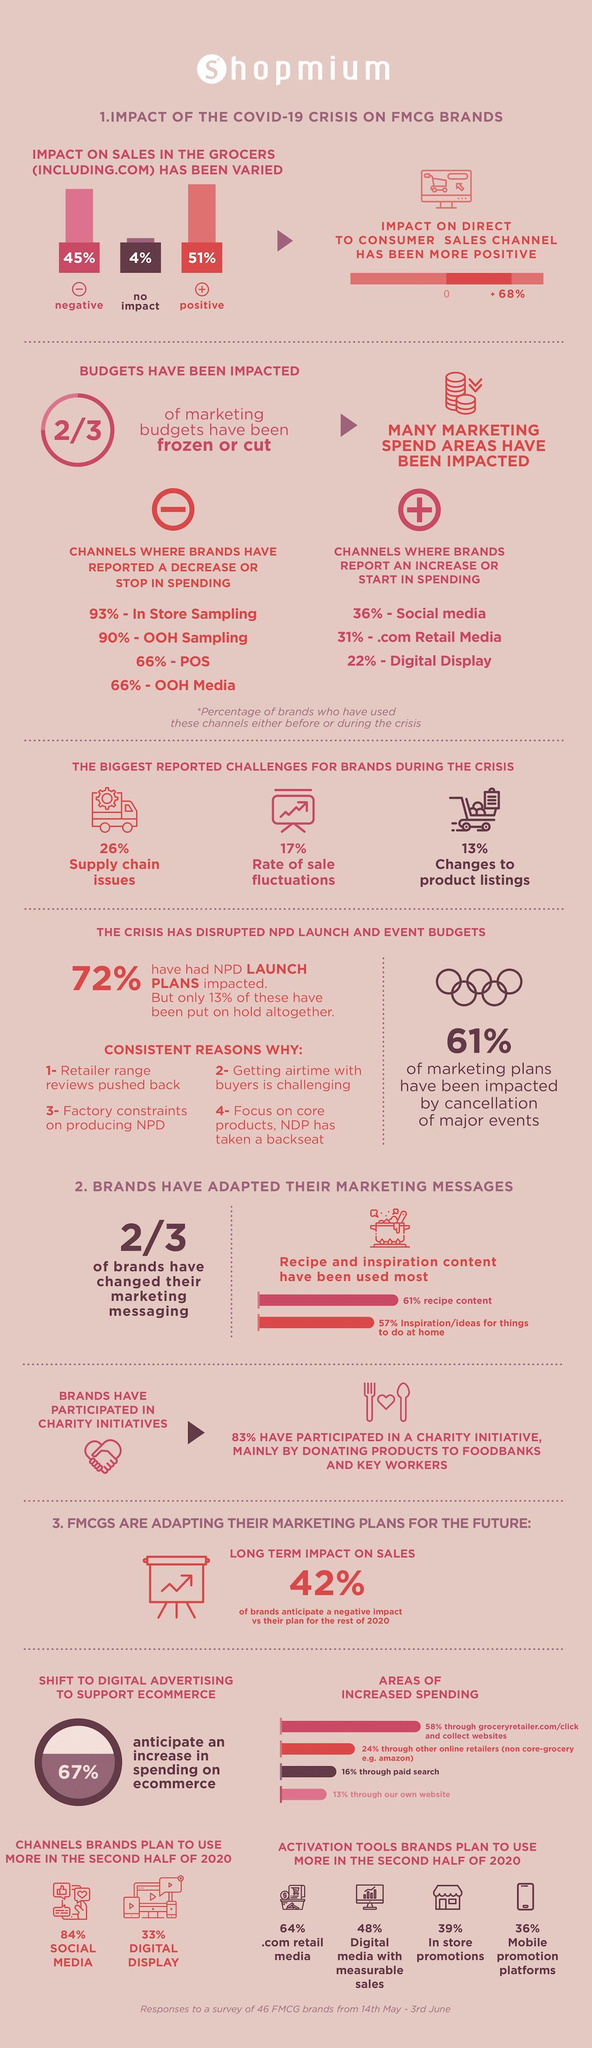What percentage of positive impact due to COVID-19 is made on the sales of FMCG product brands in the grocers?
Answer the question with a short phrase. 51% What percentage of negative impact due to COVID-19 is made on the sales of FMCG product brands in the grocers? 45% 